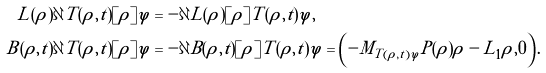Convert formula to latex. <formula><loc_0><loc_0><loc_500><loc_500>L ( \rho ) \partial T ( \rho , t ) [ \tilde { \rho } ] \varphi & = - \partial L ( \rho ) [ \tilde { \rho } ] T ( \rho , t ) \varphi , \\ B ( \rho , t ) \partial T ( \rho , t ) [ \tilde { \rho } ] \varphi & = - \partial B ( \rho , t ) [ \tilde { \rho } ] T ( \rho , t ) \varphi = \left ( - M _ { T ( \rho , t ) \varphi } P ( \rho ) \tilde { \rho } - L _ { 1 } \tilde { \rho } , 0 \right ) .</formula> 